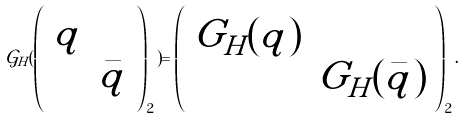Convert formula to latex. <formula><loc_0><loc_0><loc_500><loc_500>\mathcal { G } _ { H } ( \left ( \begin{array} { c c } q & \\ & \bar { q } \end{array} \right ) _ { 2 } ) = \left ( \begin{array} { c c } G _ { H } ( q ) & \\ & G _ { H } ( \bar { q } ) \end{array} \right ) _ { 2 } .</formula> 